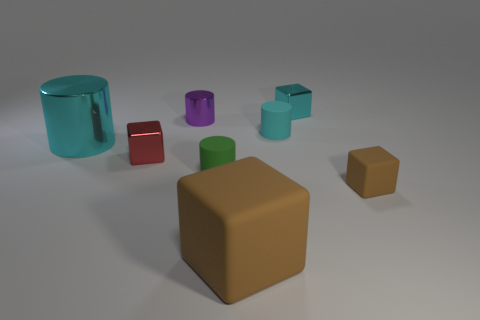Is there any other thing that is the same material as the purple cylinder?
Offer a terse response. Yes. How many other objects are there of the same material as the purple cylinder?
Offer a very short reply. 3. What number of large objects are either purple metal things or brown metal objects?
Offer a terse response. 0. Are the tiny red cube and the green cylinder made of the same material?
Offer a very short reply. No. How many tiny matte blocks are behind the shiny block behind the tiny red object?
Make the answer very short. 0. Is there a large metal object of the same shape as the large rubber thing?
Offer a very short reply. No. There is a big thing behind the small rubber cube; is its shape the same as the small metal object that is behind the small metal cylinder?
Offer a very short reply. No. What is the shape of the thing that is to the right of the small cyan matte cylinder and in front of the small cyan matte object?
Ensure brevity in your answer.  Cube. Is there a yellow thing that has the same size as the red thing?
Keep it short and to the point. No. There is a big shiny cylinder; does it have the same color as the tiny metal block behind the purple metal thing?
Make the answer very short. Yes. 